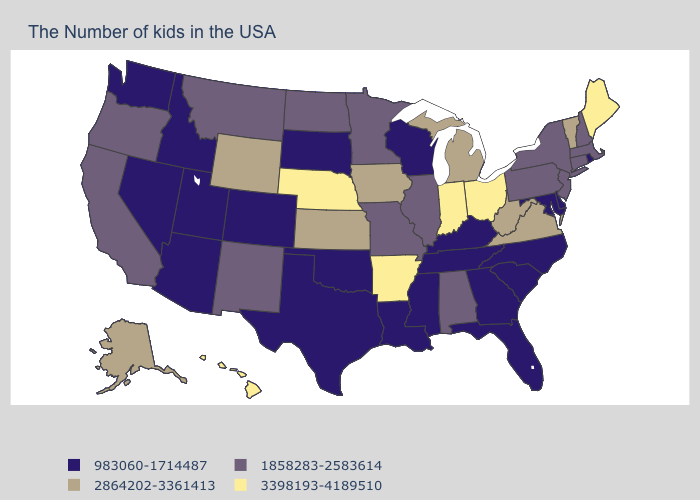What is the highest value in the Northeast ?
Short answer required. 3398193-4189510. What is the highest value in states that border Maine?
Answer briefly. 1858283-2583614. What is the value of Kansas?
Give a very brief answer. 2864202-3361413. Name the states that have a value in the range 3398193-4189510?
Answer briefly. Maine, Ohio, Indiana, Arkansas, Nebraska, Hawaii. What is the value of Massachusetts?
Keep it brief. 1858283-2583614. What is the value of Texas?
Write a very short answer. 983060-1714487. What is the value of West Virginia?
Short answer required. 2864202-3361413. Which states have the highest value in the USA?
Write a very short answer. Maine, Ohio, Indiana, Arkansas, Nebraska, Hawaii. Does the map have missing data?
Write a very short answer. No. Name the states that have a value in the range 2864202-3361413?
Concise answer only. Vermont, Virginia, West Virginia, Michigan, Iowa, Kansas, Wyoming, Alaska. Which states have the highest value in the USA?
Quick response, please. Maine, Ohio, Indiana, Arkansas, Nebraska, Hawaii. What is the value of Wisconsin?
Answer briefly. 983060-1714487. What is the highest value in the West ?
Quick response, please. 3398193-4189510. Which states have the lowest value in the West?
Answer briefly. Colorado, Utah, Arizona, Idaho, Nevada, Washington. Among the states that border Wyoming , which have the highest value?
Quick response, please. Nebraska. 